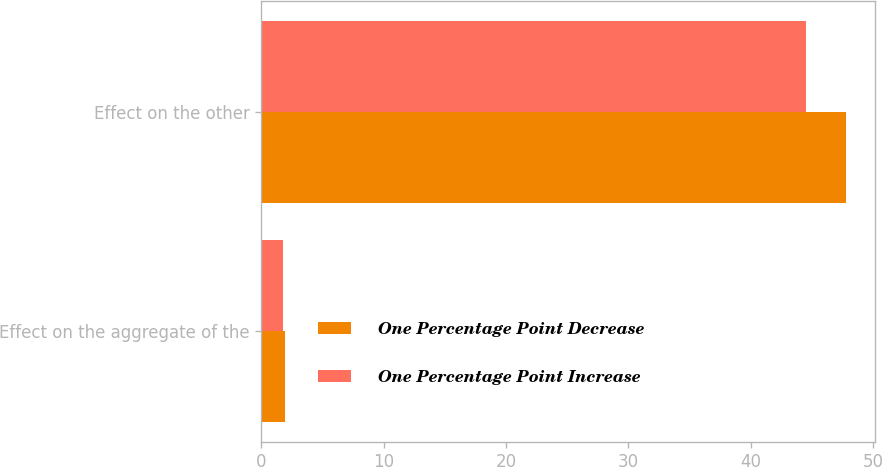Convert chart to OTSL. <chart><loc_0><loc_0><loc_500><loc_500><stacked_bar_chart><ecel><fcel>Effect on the aggregate of the<fcel>Effect on the other<nl><fcel>One Percentage Point Decrease<fcel>1.9<fcel>47.8<nl><fcel>One Percentage Point Increase<fcel>1.8<fcel>44.5<nl></chart> 